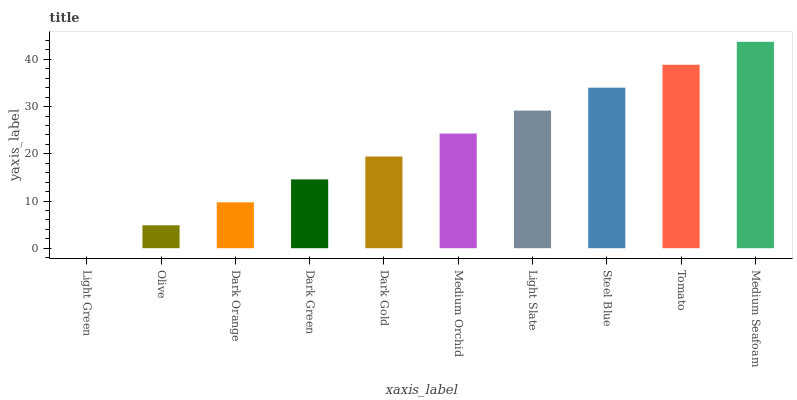Is Light Green the minimum?
Answer yes or no. Yes. Is Medium Seafoam the maximum?
Answer yes or no. Yes. Is Olive the minimum?
Answer yes or no. No. Is Olive the maximum?
Answer yes or no. No. Is Olive greater than Light Green?
Answer yes or no. Yes. Is Light Green less than Olive?
Answer yes or no. Yes. Is Light Green greater than Olive?
Answer yes or no. No. Is Olive less than Light Green?
Answer yes or no. No. Is Medium Orchid the high median?
Answer yes or no. Yes. Is Dark Gold the low median?
Answer yes or no. Yes. Is Dark Orange the high median?
Answer yes or no. No. Is Dark Orange the low median?
Answer yes or no. No. 